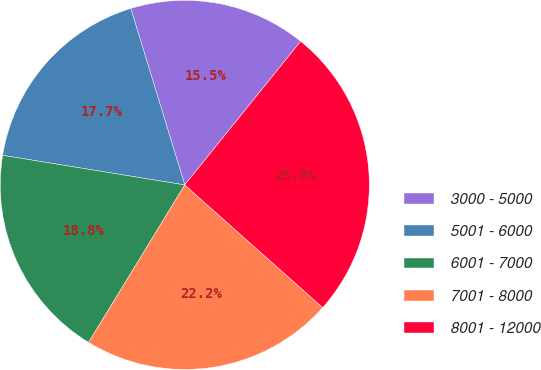Convert chart. <chart><loc_0><loc_0><loc_500><loc_500><pie_chart><fcel>3000 - 5000<fcel>5001 - 6000<fcel>6001 - 7000<fcel>7001 - 8000<fcel>8001 - 12000<nl><fcel>15.53%<fcel>17.71%<fcel>18.84%<fcel>22.16%<fcel>25.76%<nl></chart> 